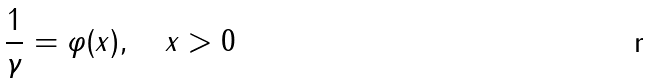<formula> <loc_0><loc_0><loc_500><loc_500>\frac { 1 } { \gamma } = \varphi ( x ) , \quad x > 0</formula> 